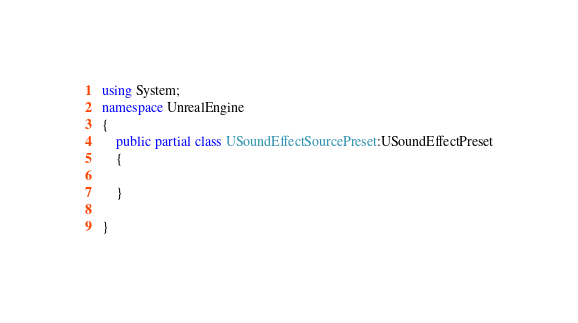<code> <loc_0><loc_0><loc_500><loc_500><_C#_>using System;
namespace UnrealEngine
{
	public partial class USoundEffectSourcePreset:USoundEffectPreset
	{
		
	}
	
}
</code> 